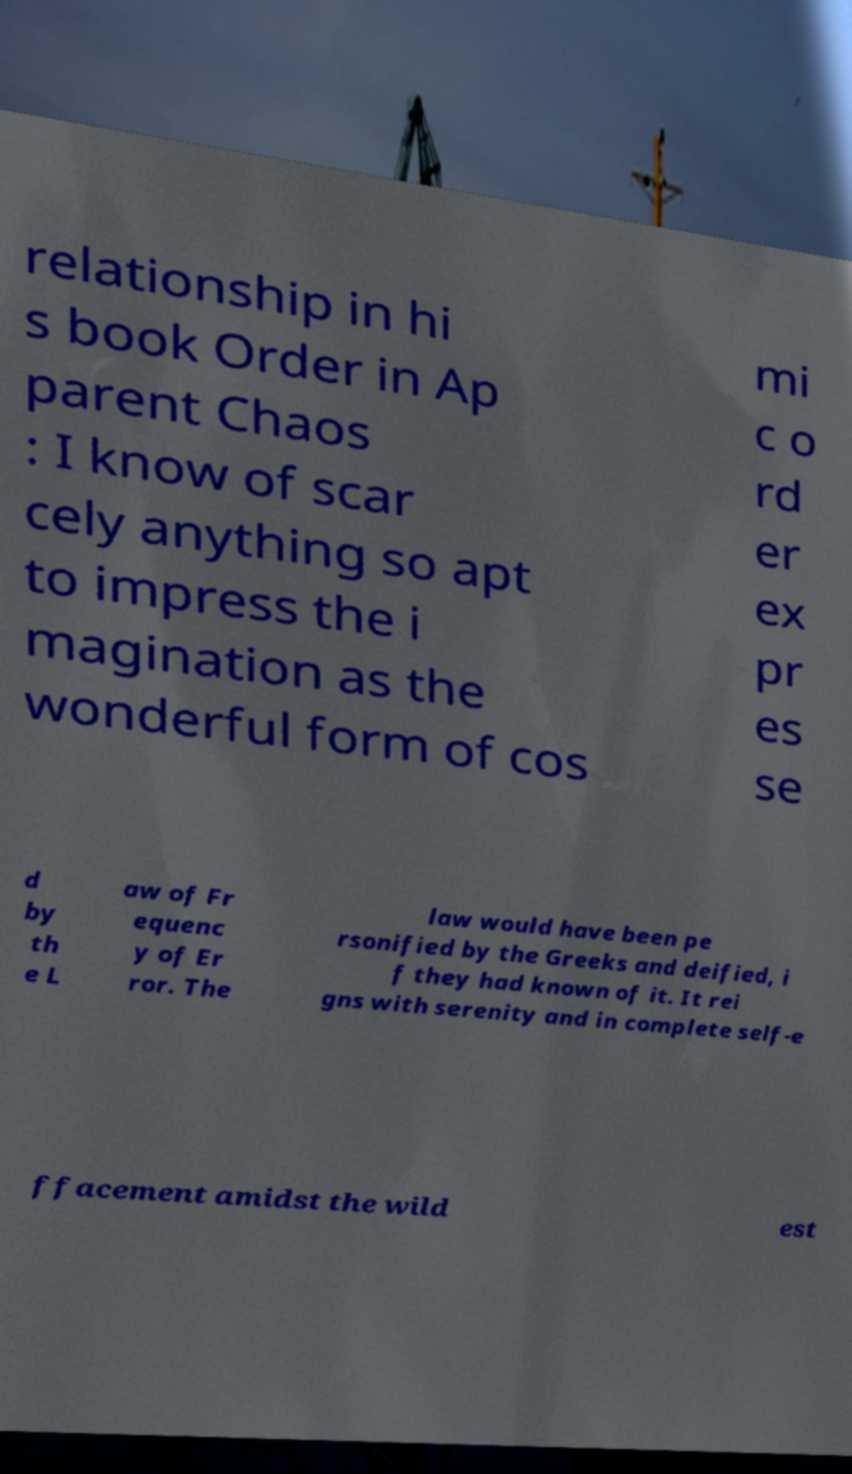I need the written content from this picture converted into text. Can you do that? relationship in hi s book Order in Ap parent Chaos : I know of scar cely anything so apt to impress the i magination as the wonderful form of cos mi c o rd er ex pr es se d by th e L aw of Fr equenc y of Er ror. The law would have been pe rsonified by the Greeks and deified, i f they had known of it. It rei gns with serenity and in complete self-e ffacement amidst the wild est 